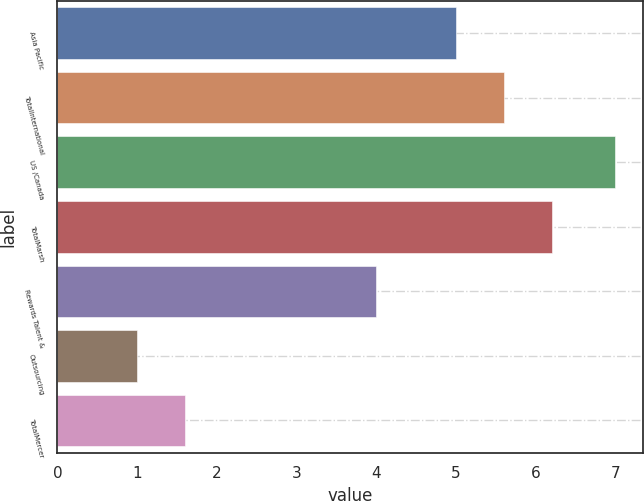<chart> <loc_0><loc_0><loc_500><loc_500><bar_chart><fcel>Asia Pacific<fcel>TotalInternational<fcel>US /Canada<fcel>TotalMarsh<fcel>Rewards Talent &<fcel>Outsourcing<fcel>TotalMercer<nl><fcel>5<fcel>5.6<fcel>7<fcel>6.2<fcel>4<fcel>1<fcel>1.6<nl></chart> 